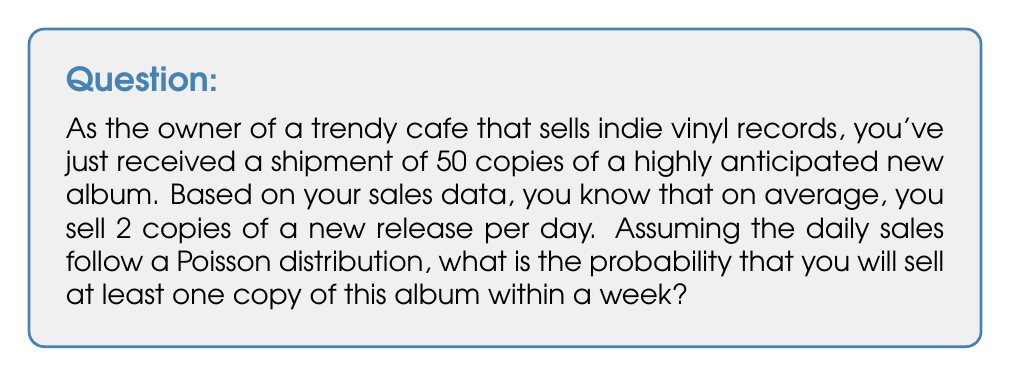What is the answer to this math problem? To solve this problem, we need to follow these steps:

1. Calculate the average number of sales in a week:
   $\lambda = 2 \text{ copies/day} \times 7 \text{ days} = 14 \text{ copies/week}$

2. We want to find the probability of selling at least one copy, which is the complement of selling zero copies.

3. The probability of selling exactly $k$ copies in a week follows a Poisson distribution:

   $$P(X = k) = \frac{e^{-\lambda}\lambda^k}{k!}$$

4. The probability of selling zero copies is:

   $$P(X = 0) = \frac{e^{-14}14^0}{0!} = e^{-14}$$

5. The probability of selling at least one copy is the complement of selling zero copies:

   $$P(X \geq 1) = 1 - P(X = 0) = 1 - e^{-14}$$

6. Calculate the final result:

   $$1 - e^{-14} \approx 0.9999999999999

Therefore, the probability of selling at least one copy of the album within a week is approximately 0.9999999999999 or 99.99999999999%.
Answer: $1 - e^{-14} \approx 0.9999999999999$ or 99.99999999999% 